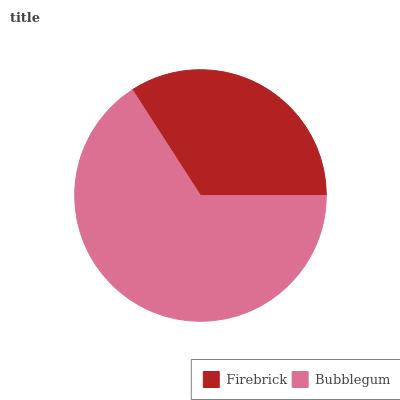Is Firebrick the minimum?
Answer yes or no. Yes. Is Bubblegum the maximum?
Answer yes or no. Yes. Is Bubblegum the minimum?
Answer yes or no. No. Is Bubblegum greater than Firebrick?
Answer yes or no. Yes. Is Firebrick less than Bubblegum?
Answer yes or no. Yes. Is Firebrick greater than Bubblegum?
Answer yes or no. No. Is Bubblegum less than Firebrick?
Answer yes or no. No. Is Bubblegum the high median?
Answer yes or no. Yes. Is Firebrick the low median?
Answer yes or no. Yes. Is Firebrick the high median?
Answer yes or no. No. Is Bubblegum the low median?
Answer yes or no. No. 